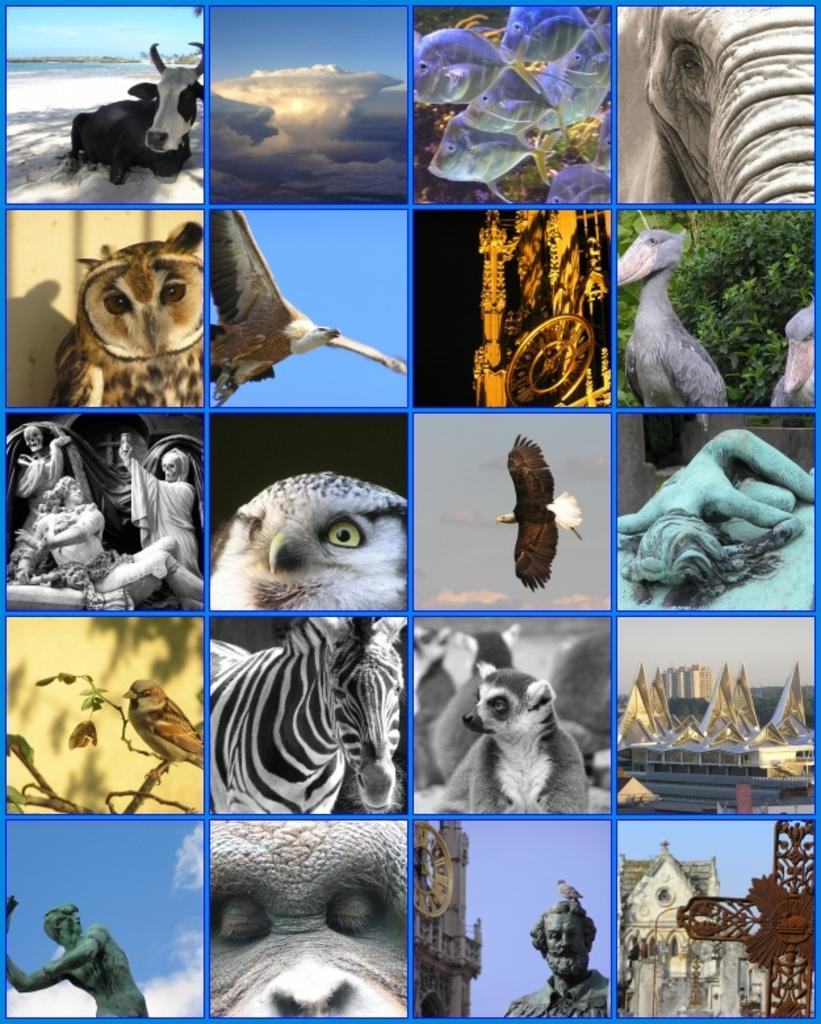What type of animal can be seen in the image? There is a cow, a zebra, and an owl in the image. Can you describe the other subjects in the image besides the animals? There are sculptures in the image. What type of ocean can be seen in the image? There is no ocean present in the image; it features a cow, a zebra, an owl, and sculptures. Can you provide an example of a statement that is not present in the image? It is not possible to provide an example of a statement that is not present in the image, as the image only contains visual elements. 